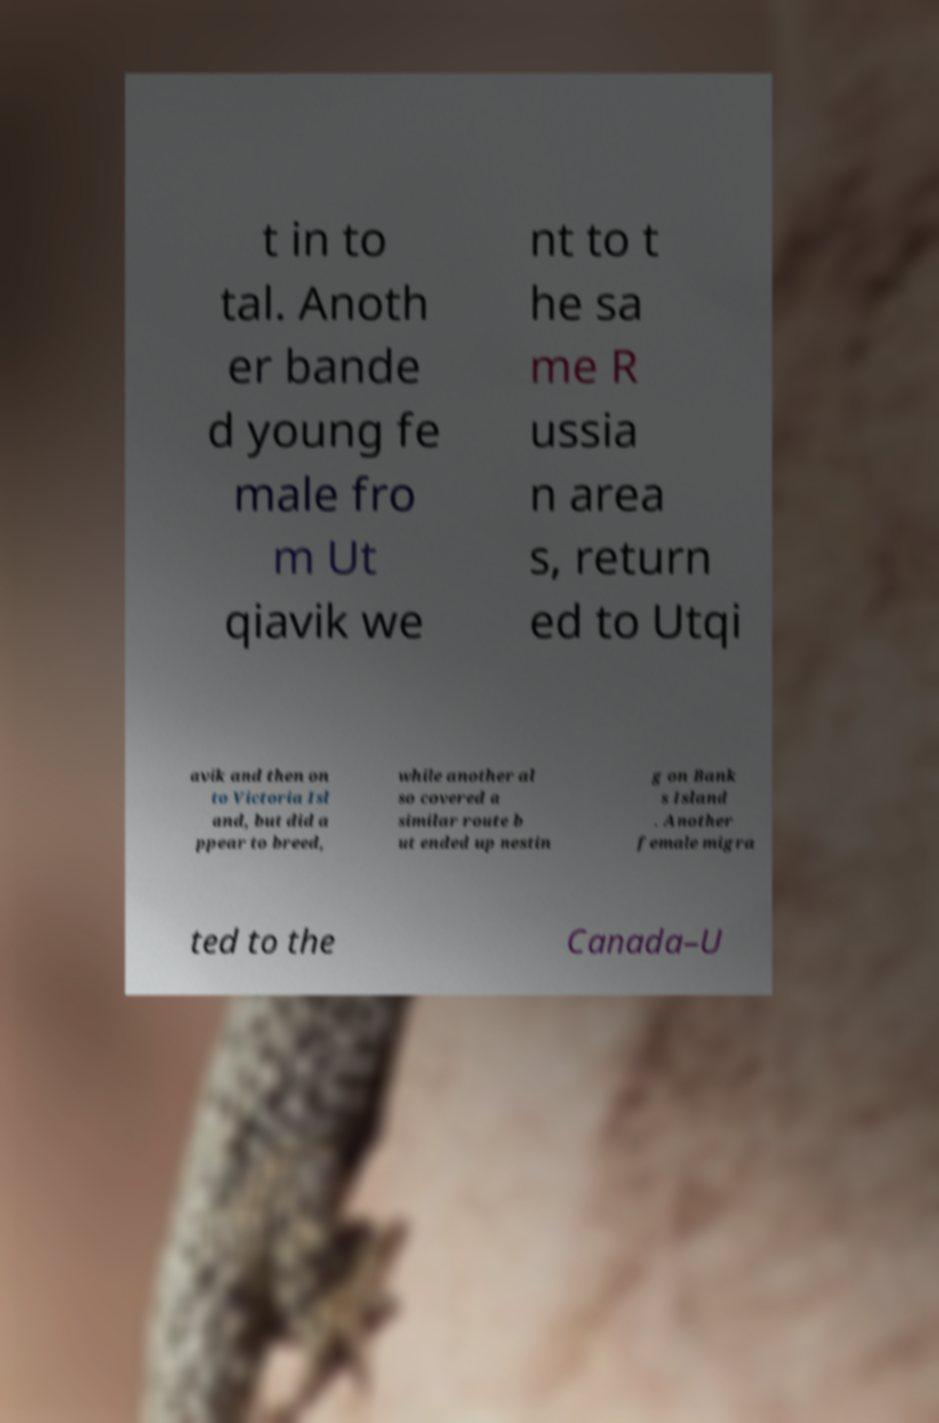Could you extract and type out the text from this image? t in to tal. Anoth er bande d young fe male fro m Ut qiavik we nt to t he sa me R ussia n area s, return ed to Utqi avik and then on to Victoria Isl and, but did a ppear to breed, while another al so covered a similar route b ut ended up nestin g on Bank s Island . Another female migra ted to the Canada–U 